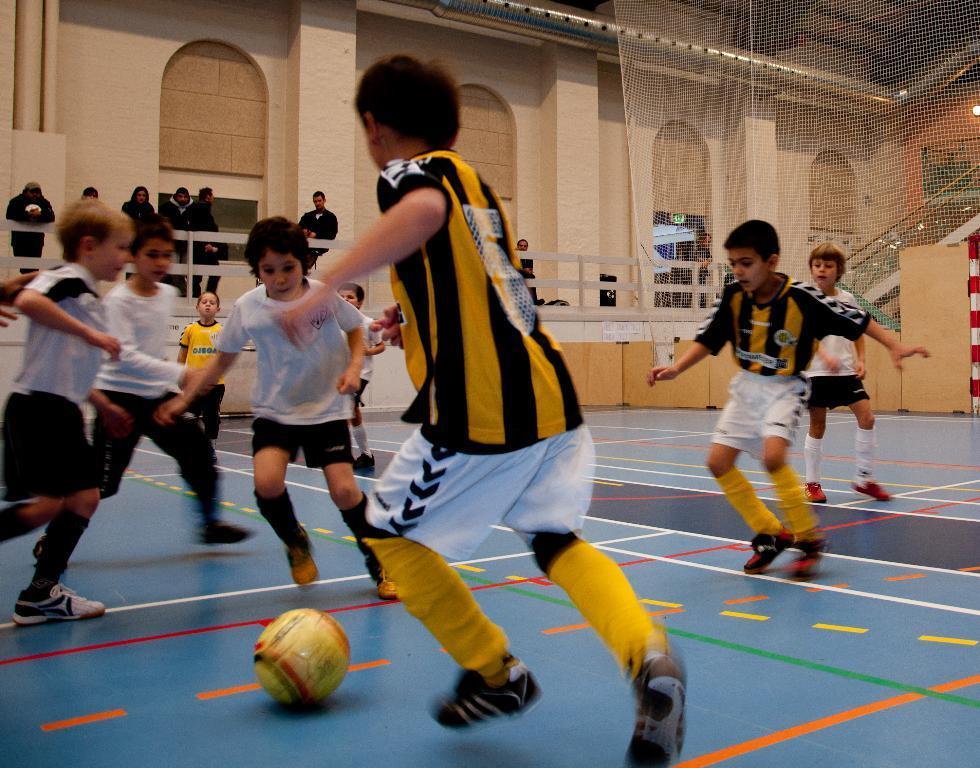How would you summarize this image in a sentence or two? In the picture we can see group of kids wearing sports dress playing football, there is ball, on right side of the picture there is net and in the background of the picture there are some persons standing behind railing, there is a wall. 